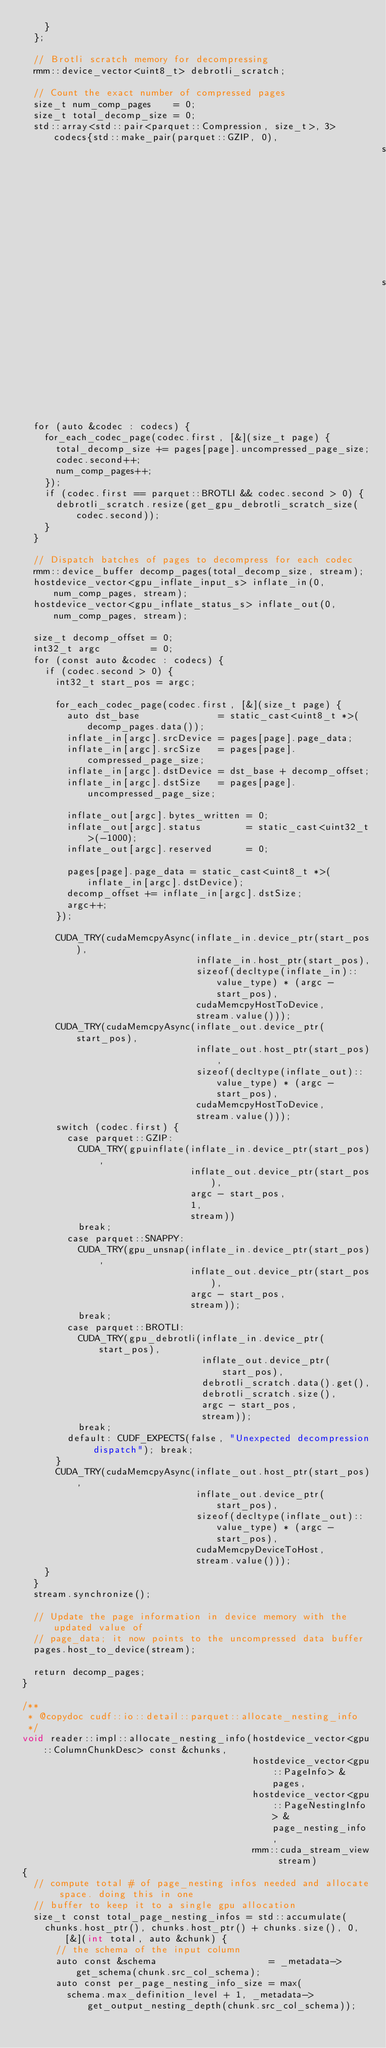<code> <loc_0><loc_0><loc_500><loc_500><_Cuda_>    }
  };

  // Brotli scratch memory for decompressing
  rmm::device_vector<uint8_t> debrotli_scratch;

  // Count the exact number of compressed pages
  size_t num_comp_pages    = 0;
  size_t total_decomp_size = 0;
  std::array<std::pair<parquet::Compression, size_t>, 3> codecs{std::make_pair(parquet::GZIP, 0),
                                                                std::make_pair(parquet::SNAPPY, 0),
                                                                std::make_pair(parquet::BROTLI, 0)};

  for (auto &codec : codecs) {
    for_each_codec_page(codec.first, [&](size_t page) {
      total_decomp_size += pages[page].uncompressed_page_size;
      codec.second++;
      num_comp_pages++;
    });
    if (codec.first == parquet::BROTLI && codec.second > 0) {
      debrotli_scratch.resize(get_gpu_debrotli_scratch_size(codec.second));
    }
  }

  // Dispatch batches of pages to decompress for each codec
  rmm::device_buffer decomp_pages(total_decomp_size, stream);
  hostdevice_vector<gpu_inflate_input_s> inflate_in(0, num_comp_pages, stream);
  hostdevice_vector<gpu_inflate_status_s> inflate_out(0, num_comp_pages, stream);

  size_t decomp_offset = 0;
  int32_t argc         = 0;
  for (const auto &codec : codecs) {
    if (codec.second > 0) {
      int32_t start_pos = argc;

      for_each_codec_page(codec.first, [&](size_t page) {
        auto dst_base              = static_cast<uint8_t *>(decomp_pages.data());
        inflate_in[argc].srcDevice = pages[page].page_data;
        inflate_in[argc].srcSize   = pages[page].compressed_page_size;
        inflate_in[argc].dstDevice = dst_base + decomp_offset;
        inflate_in[argc].dstSize   = pages[page].uncompressed_page_size;

        inflate_out[argc].bytes_written = 0;
        inflate_out[argc].status        = static_cast<uint32_t>(-1000);
        inflate_out[argc].reserved      = 0;

        pages[page].page_data = static_cast<uint8_t *>(inflate_in[argc].dstDevice);
        decomp_offset += inflate_in[argc].dstSize;
        argc++;
      });

      CUDA_TRY(cudaMemcpyAsync(inflate_in.device_ptr(start_pos),
                               inflate_in.host_ptr(start_pos),
                               sizeof(decltype(inflate_in)::value_type) * (argc - start_pos),
                               cudaMemcpyHostToDevice,
                               stream.value()));
      CUDA_TRY(cudaMemcpyAsync(inflate_out.device_ptr(start_pos),
                               inflate_out.host_ptr(start_pos),
                               sizeof(decltype(inflate_out)::value_type) * (argc - start_pos),
                               cudaMemcpyHostToDevice,
                               stream.value()));
      switch (codec.first) {
        case parquet::GZIP:
          CUDA_TRY(gpuinflate(inflate_in.device_ptr(start_pos),
                              inflate_out.device_ptr(start_pos),
                              argc - start_pos,
                              1,
                              stream))
          break;
        case parquet::SNAPPY:
          CUDA_TRY(gpu_unsnap(inflate_in.device_ptr(start_pos),
                              inflate_out.device_ptr(start_pos),
                              argc - start_pos,
                              stream));
          break;
        case parquet::BROTLI:
          CUDA_TRY(gpu_debrotli(inflate_in.device_ptr(start_pos),
                                inflate_out.device_ptr(start_pos),
                                debrotli_scratch.data().get(),
                                debrotli_scratch.size(),
                                argc - start_pos,
                                stream));
          break;
        default: CUDF_EXPECTS(false, "Unexpected decompression dispatch"); break;
      }
      CUDA_TRY(cudaMemcpyAsync(inflate_out.host_ptr(start_pos),
                               inflate_out.device_ptr(start_pos),
                               sizeof(decltype(inflate_out)::value_type) * (argc - start_pos),
                               cudaMemcpyDeviceToHost,
                               stream.value()));
    }
  }
  stream.synchronize();

  // Update the page information in device memory with the updated value of
  // page_data; it now points to the uncompressed data buffer
  pages.host_to_device(stream);

  return decomp_pages;
}

/**
 * @copydoc cudf::io::detail::parquet::allocate_nesting_info
 */
void reader::impl::allocate_nesting_info(hostdevice_vector<gpu::ColumnChunkDesc> const &chunks,
                                         hostdevice_vector<gpu::PageInfo> &pages,
                                         hostdevice_vector<gpu::PageNestingInfo> &page_nesting_info,
                                         rmm::cuda_stream_view stream)
{
  // compute total # of page_nesting infos needed and allocate space. doing this in one
  // buffer to keep it to a single gpu allocation
  size_t const total_page_nesting_infos = std::accumulate(
    chunks.host_ptr(), chunks.host_ptr() + chunks.size(), 0, [&](int total, auto &chunk) {
      // the schema of the input column
      auto const &schema                    = _metadata->get_schema(chunk.src_col_schema);
      auto const per_page_nesting_info_size = max(
        schema.max_definition_level + 1, _metadata->get_output_nesting_depth(chunk.src_col_schema));</code> 